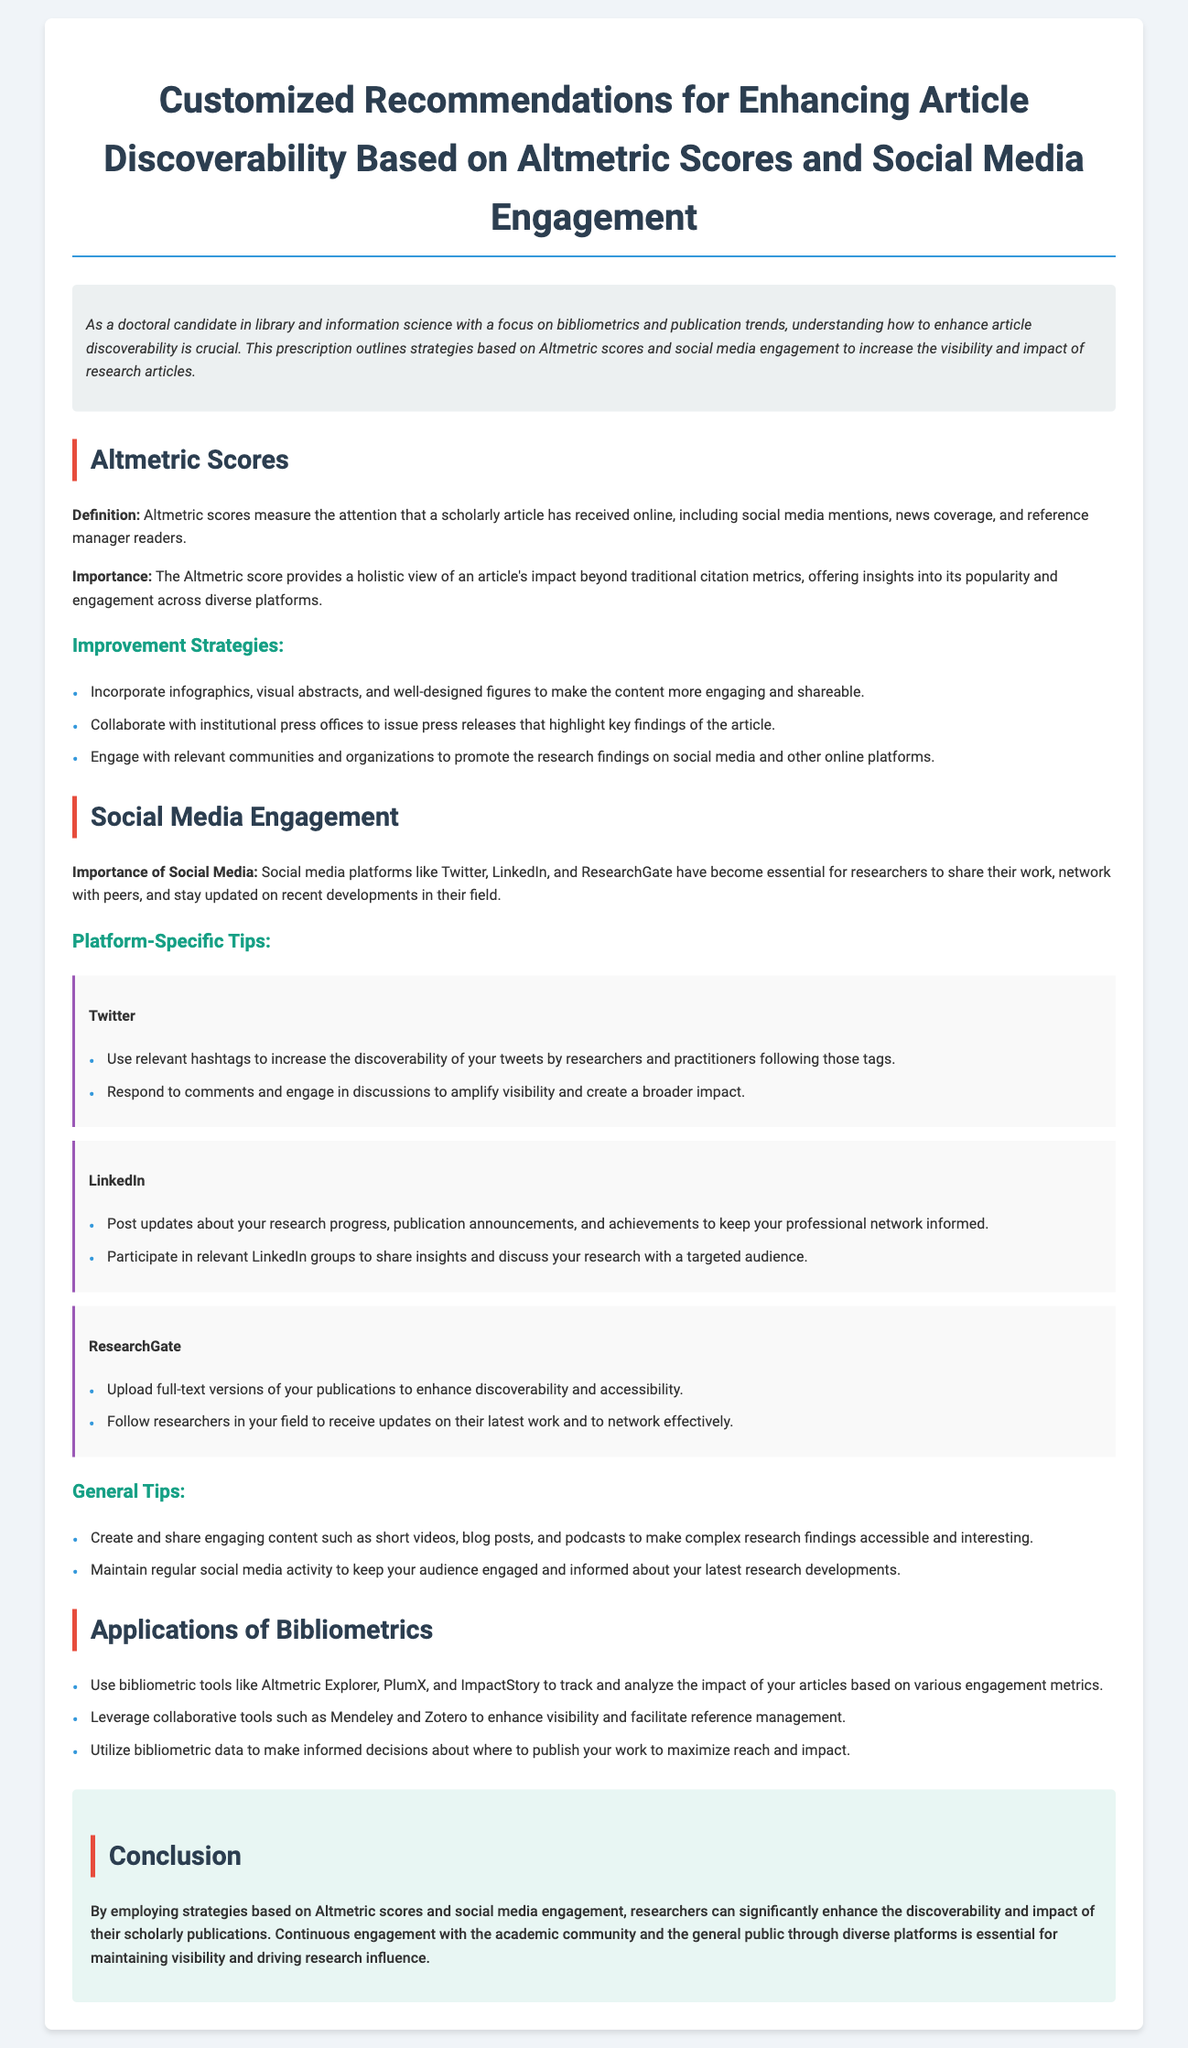what is the title of the document? The title of the document is prominently displayed at the top and indicates the main focus of the content.
Answer: Customized Recommendations for Enhancing Article Discoverability Based on Altmetric Scores and Social Media Engagement what do Altmetric scores measure? Altmetric scores measure the attention that a scholarly article has received online, which is mentioned under the section for Altmetric Scores.
Answer: Attention of scholarly articles why is social media important for researchers? The document highlights the importance of social media as a tool for sharing work and networking, specifically in the section related to Social Media Engagement.
Answer: Sharing work and networking list one improvement strategy for Altmetric scores. The document provides strategies for improvement in the Altmetric Scores section and requests a specific strategy.
Answer: Incorporate infographics what is a platform-specific tip for Twitter? The document contains tips specific to different platforms, and the question asks specifically about Twitter.
Answer: Use relevant hashtags name a bibliometric tool mentioned in the document. The Applications of Bibliometrics section lists tools used for tracking and analyzing research impact.
Answer: Altmetric Explorer what is one general tip for social media engagement? The section on General Tips provides advice for maintaining an active presence on social media.
Answer: Maintain regular social media activity how can researchers improve their discoverability? The question requires synthesizing information about strategies presented throughout the document that enhance visibility.
Answer: Strategies based on Altmetric scores and social media engagement 